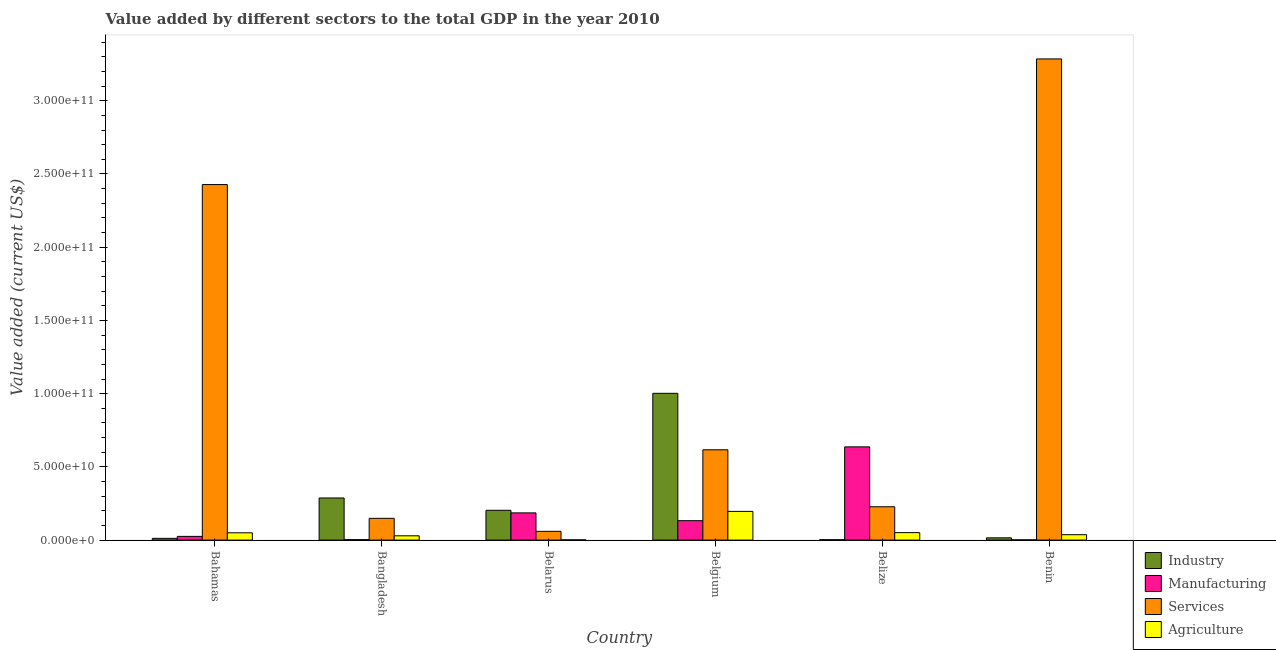Are the number of bars per tick equal to the number of legend labels?
Ensure brevity in your answer.  Yes. Are the number of bars on each tick of the X-axis equal?
Provide a short and direct response. Yes. How many bars are there on the 5th tick from the right?
Give a very brief answer. 4. What is the label of the 4th group of bars from the left?
Keep it short and to the point. Belgium. What is the value added by services sector in Benin?
Ensure brevity in your answer.  3.29e+11. Across all countries, what is the maximum value added by industrial sector?
Provide a short and direct response. 1.00e+11. Across all countries, what is the minimum value added by services sector?
Provide a short and direct response. 5.99e+09. In which country was the value added by agricultural sector maximum?
Keep it short and to the point. Belgium. In which country was the value added by agricultural sector minimum?
Keep it short and to the point. Belarus. What is the total value added by agricultural sector in the graph?
Keep it short and to the point. 3.65e+1. What is the difference between the value added by services sector in Belgium and that in Belize?
Keep it short and to the point. 3.89e+1. What is the difference between the value added by agricultural sector in Benin and the value added by services sector in Belarus?
Offer a very short reply. -2.30e+09. What is the average value added by services sector per country?
Your response must be concise. 1.13e+11. What is the difference between the value added by services sector and value added by agricultural sector in Belize?
Offer a terse response. 1.77e+1. What is the ratio of the value added by industrial sector in Bangladesh to that in Belize?
Ensure brevity in your answer.  109.35. Is the value added by agricultural sector in Bangladesh less than that in Belize?
Your answer should be very brief. Yes. Is the difference between the value added by manufacturing sector in Bangladesh and Belgium greater than the difference between the value added by services sector in Bangladesh and Belgium?
Offer a very short reply. Yes. What is the difference between the highest and the second highest value added by agricultural sector?
Keep it short and to the point. 1.45e+1. What is the difference between the highest and the lowest value added by agricultural sector?
Your answer should be very brief. 1.94e+1. Is the sum of the value added by industrial sector in Belgium and Belize greater than the maximum value added by services sector across all countries?
Ensure brevity in your answer.  No. What does the 4th bar from the left in Belgium represents?
Your response must be concise. Agriculture. What does the 2nd bar from the right in Bahamas represents?
Make the answer very short. Services. Is it the case that in every country, the sum of the value added by industrial sector and value added by manufacturing sector is greater than the value added by services sector?
Keep it short and to the point. No. Are all the bars in the graph horizontal?
Give a very brief answer. No. What is the difference between two consecutive major ticks on the Y-axis?
Make the answer very short. 5.00e+1. Are the values on the major ticks of Y-axis written in scientific E-notation?
Provide a short and direct response. Yes. Does the graph contain any zero values?
Offer a very short reply. No. Does the graph contain grids?
Offer a terse response. No. How many legend labels are there?
Provide a succinct answer. 4. How are the legend labels stacked?
Make the answer very short. Vertical. What is the title of the graph?
Offer a terse response. Value added by different sectors to the total GDP in the year 2010. Does "Taxes on income" appear as one of the legend labels in the graph?
Keep it short and to the point. No. What is the label or title of the Y-axis?
Your response must be concise. Value added (current US$). What is the Value added (current US$) in Industry in Bahamas?
Your response must be concise. 1.20e+09. What is the Value added (current US$) of Manufacturing in Bahamas?
Make the answer very short. 2.54e+09. What is the Value added (current US$) of Services in Bahamas?
Offer a terse response. 2.43e+11. What is the Value added (current US$) of Agriculture in Bahamas?
Offer a very short reply. 4.98e+09. What is the Value added (current US$) of Industry in Bangladesh?
Your answer should be very brief. 2.88e+1. What is the Value added (current US$) in Manufacturing in Bangladesh?
Offer a very short reply. 2.96e+08. What is the Value added (current US$) in Services in Bangladesh?
Your answer should be compact. 1.49e+1. What is the Value added (current US$) of Agriculture in Bangladesh?
Offer a very short reply. 2.93e+09. What is the Value added (current US$) of Industry in Belarus?
Provide a succinct answer. 2.03e+1. What is the Value added (current US$) in Manufacturing in Belarus?
Your response must be concise. 1.86e+1. What is the Value added (current US$) of Services in Belarus?
Your response must be concise. 5.99e+09. What is the Value added (current US$) in Agriculture in Belarus?
Offer a very short reply. 1.70e+08. What is the Value added (current US$) of Industry in Belgium?
Give a very brief answer. 1.00e+11. What is the Value added (current US$) of Manufacturing in Belgium?
Offer a very short reply. 1.33e+1. What is the Value added (current US$) in Services in Belgium?
Offer a terse response. 6.17e+1. What is the Value added (current US$) of Agriculture in Belgium?
Give a very brief answer. 1.96e+1. What is the Value added (current US$) of Industry in Belize?
Offer a very short reply. 2.63e+08. What is the Value added (current US$) of Manufacturing in Belize?
Keep it short and to the point. 6.37e+1. What is the Value added (current US$) of Services in Belize?
Provide a succinct answer. 2.28e+1. What is the Value added (current US$) in Agriculture in Belize?
Ensure brevity in your answer.  5.10e+09. What is the Value added (current US$) in Industry in Benin?
Provide a short and direct response. 1.54e+09. What is the Value added (current US$) in Manufacturing in Benin?
Your response must be concise. 1.71e+08. What is the Value added (current US$) in Services in Benin?
Provide a succinct answer. 3.29e+11. What is the Value added (current US$) in Agriculture in Benin?
Provide a succinct answer. 3.69e+09. Across all countries, what is the maximum Value added (current US$) of Industry?
Ensure brevity in your answer.  1.00e+11. Across all countries, what is the maximum Value added (current US$) in Manufacturing?
Offer a very short reply. 6.37e+1. Across all countries, what is the maximum Value added (current US$) of Services?
Provide a short and direct response. 3.29e+11. Across all countries, what is the maximum Value added (current US$) in Agriculture?
Your answer should be very brief. 1.96e+1. Across all countries, what is the minimum Value added (current US$) of Industry?
Provide a short and direct response. 2.63e+08. Across all countries, what is the minimum Value added (current US$) of Manufacturing?
Your response must be concise. 1.71e+08. Across all countries, what is the minimum Value added (current US$) in Services?
Make the answer very short. 5.99e+09. Across all countries, what is the minimum Value added (current US$) in Agriculture?
Your response must be concise. 1.70e+08. What is the total Value added (current US$) in Industry in the graph?
Offer a very short reply. 1.52e+11. What is the total Value added (current US$) in Manufacturing in the graph?
Provide a short and direct response. 9.85e+1. What is the total Value added (current US$) of Services in the graph?
Your response must be concise. 6.77e+11. What is the total Value added (current US$) of Agriculture in the graph?
Your answer should be very brief. 3.65e+1. What is the difference between the Value added (current US$) of Industry in Bahamas and that in Bangladesh?
Ensure brevity in your answer.  -2.76e+1. What is the difference between the Value added (current US$) in Manufacturing in Bahamas and that in Bangladesh?
Your response must be concise. 2.25e+09. What is the difference between the Value added (current US$) of Services in Bahamas and that in Bangladesh?
Offer a terse response. 2.28e+11. What is the difference between the Value added (current US$) of Agriculture in Bahamas and that in Bangladesh?
Your answer should be very brief. 2.05e+09. What is the difference between the Value added (current US$) of Industry in Bahamas and that in Belarus?
Make the answer very short. -1.92e+1. What is the difference between the Value added (current US$) of Manufacturing in Bahamas and that in Belarus?
Keep it short and to the point. -1.60e+1. What is the difference between the Value added (current US$) in Services in Bahamas and that in Belarus?
Provide a succinct answer. 2.37e+11. What is the difference between the Value added (current US$) of Agriculture in Bahamas and that in Belarus?
Offer a terse response. 4.81e+09. What is the difference between the Value added (current US$) of Industry in Bahamas and that in Belgium?
Make the answer very short. -9.90e+1. What is the difference between the Value added (current US$) of Manufacturing in Bahamas and that in Belgium?
Provide a succinct answer. -1.07e+1. What is the difference between the Value added (current US$) in Services in Bahamas and that in Belgium?
Offer a terse response. 1.81e+11. What is the difference between the Value added (current US$) in Agriculture in Bahamas and that in Belgium?
Make the answer very short. -1.46e+1. What is the difference between the Value added (current US$) of Industry in Bahamas and that in Belize?
Keep it short and to the point. 9.34e+08. What is the difference between the Value added (current US$) in Manufacturing in Bahamas and that in Belize?
Provide a succinct answer. -6.11e+1. What is the difference between the Value added (current US$) of Services in Bahamas and that in Belize?
Offer a very short reply. 2.20e+11. What is the difference between the Value added (current US$) of Agriculture in Bahamas and that in Belize?
Your response must be concise. -1.13e+08. What is the difference between the Value added (current US$) in Industry in Bahamas and that in Benin?
Provide a short and direct response. -3.46e+08. What is the difference between the Value added (current US$) of Manufacturing in Bahamas and that in Benin?
Your answer should be compact. 2.37e+09. What is the difference between the Value added (current US$) of Services in Bahamas and that in Benin?
Ensure brevity in your answer.  -8.58e+1. What is the difference between the Value added (current US$) of Agriculture in Bahamas and that in Benin?
Your answer should be compact. 1.30e+09. What is the difference between the Value added (current US$) of Industry in Bangladesh and that in Belarus?
Your answer should be very brief. 8.42e+09. What is the difference between the Value added (current US$) in Manufacturing in Bangladesh and that in Belarus?
Provide a short and direct response. -1.83e+1. What is the difference between the Value added (current US$) of Services in Bangladesh and that in Belarus?
Your answer should be very brief. 8.88e+09. What is the difference between the Value added (current US$) of Agriculture in Bangladesh and that in Belarus?
Offer a very short reply. 2.76e+09. What is the difference between the Value added (current US$) of Industry in Bangladesh and that in Belgium?
Offer a terse response. -7.15e+1. What is the difference between the Value added (current US$) of Manufacturing in Bangladesh and that in Belgium?
Make the answer very short. -1.30e+1. What is the difference between the Value added (current US$) in Services in Bangladesh and that in Belgium?
Provide a short and direct response. -4.68e+1. What is the difference between the Value added (current US$) in Agriculture in Bangladesh and that in Belgium?
Give a very brief answer. -1.67e+1. What is the difference between the Value added (current US$) in Industry in Bangladesh and that in Belize?
Your answer should be very brief. 2.85e+1. What is the difference between the Value added (current US$) in Manufacturing in Bangladesh and that in Belize?
Make the answer very short. -6.34e+1. What is the difference between the Value added (current US$) in Services in Bangladesh and that in Belize?
Offer a terse response. -7.90e+09. What is the difference between the Value added (current US$) in Agriculture in Bangladesh and that in Belize?
Make the answer very short. -2.16e+09. What is the difference between the Value added (current US$) of Industry in Bangladesh and that in Benin?
Ensure brevity in your answer.  2.72e+1. What is the difference between the Value added (current US$) of Manufacturing in Bangladesh and that in Benin?
Keep it short and to the point. 1.26e+08. What is the difference between the Value added (current US$) of Services in Bangladesh and that in Benin?
Offer a terse response. -3.14e+11. What is the difference between the Value added (current US$) in Agriculture in Bangladesh and that in Benin?
Make the answer very short. -7.54e+08. What is the difference between the Value added (current US$) in Industry in Belarus and that in Belgium?
Give a very brief answer. -7.99e+1. What is the difference between the Value added (current US$) in Manufacturing in Belarus and that in Belgium?
Your answer should be very brief. 5.32e+09. What is the difference between the Value added (current US$) of Services in Belarus and that in Belgium?
Your answer should be compact. -5.57e+1. What is the difference between the Value added (current US$) in Agriculture in Belarus and that in Belgium?
Offer a terse response. -1.94e+1. What is the difference between the Value added (current US$) of Industry in Belarus and that in Belize?
Your response must be concise. 2.01e+1. What is the difference between the Value added (current US$) of Manufacturing in Belarus and that in Belize?
Offer a very short reply. -4.51e+1. What is the difference between the Value added (current US$) of Services in Belarus and that in Belize?
Keep it short and to the point. -1.68e+1. What is the difference between the Value added (current US$) of Agriculture in Belarus and that in Belize?
Provide a succinct answer. -4.93e+09. What is the difference between the Value added (current US$) of Industry in Belarus and that in Benin?
Provide a succinct answer. 1.88e+1. What is the difference between the Value added (current US$) in Manufacturing in Belarus and that in Benin?
Give a very brief answer. 1.84e+1. What is the difference between the Value added (current US$) in Services in Belarus and that in Benin?
Your response must be concise. -3.23e+11. What is the difference between the Value added (current US$) in Agriculture in Belarus and that in Benin?
Your answer should be very brief. -3.52e+09. What is the difference between the Value added (current US$) in Industry in Belgium and that in Belize?
Provide a succinct answer. 1.00e+11. What is the difference between the Value added (current US$) of Manufacturing in Belgium and that in Belize?
Your response must be concise. -5.04e+1. What is the difference between the Value added (current US$) of Services in Belgium and that in Belize?
Your response must be concise. 3.89e+1. What is the difference between the Value added (current US$) in Agriculture in Belgium and that in Belize?
Your response must be concise. 1.45e+1. What is the difference between the Value added (current US$) in Industry in Belgium and that in Benin?
Your answer should be compact. 9.87e+1. What is the difference between the Value added (current US$) of Manufacturing in Belgium and that in Benin?
Give a very brief answer. 1.31e+1. What is the difference between the Value added (current US$) in Services in Belgium and that in Benin?
Offer a very short reply. -2.67e+11. What is the difference between the Value added (current US$) in Agriculture in Belgium and that in Benin?
Offer a very short reply. 1.59e+1. What is the difference between the Value added (current US$) in Industry in Belize and that in Benin?
Provide a succinct answer. -1.28e+09. What is the difference between the Value added (current US$) in Manufacturing in Belize and that in Benin?
Ensure brevity in your answer.  6.35e+1. What is the difference between the Value added (current US$) in Services in Belize and that in Benin?
Provide a succinct answer. -3.06e+11. What is the difference between the Value added (current US$) of Agriculture in Belize and that in Benin?
Your answer should be very brief. 1.41e+09. What is the difference between the Value added (current US$) of Industry in Bahamas and the Value added (current US$) of Manufacturing in Bangladesh?
Keep it short and to the point. 9.01e+08. What is the difference between the Value added (current US$) in Industry in Bahamas and the Value added (current US$) in Services in Bangladesh?
Give a very brief answer. -1.37e+1. What is the difference between the Value added (current US$) in Industry in Bahamas and the Value added (current US$) in Agriculture in Bangladesh?
Your answer should be very brief. -1.74e+09. What is the difference between the Value added (current US$) of Manufacturing in Bahamas and the Value added (current US$) of Services in Bangladesh?
Provide a short and direct response. -1.23e+1. What is the difference between the Value added (current US$) in Manufacturing in Bahamas and the Value added (current US$) in Agriculture in Bangladesh?
Your response must be concise. -3.90e+08. What is the difference between the Value added (current US$) in Services in Bahamas and the Value added (current US$) in Agriculture in Bangladesh?
Keep it short and to the point. 2.40e+11. What is the difference between the Value added (current US$) of Industry in Bahamas and the Value added (current US$) of Manufacturing in Belarus?
Make the answer very short. -1.74e+1. What is the difference between the Value added (current US$) of Industry in Bahamas and the Value added (current US$) of Services in Belarus?
Offer a terse response. -4.79e+09. What is the difference between the Value added (current US$) in Industry in Bahamas and the Value added (current US$) in Agriculture in Belarus?
Offer a very short reply. 1.03e+09. What is the difference between the Value added (current US$) of Manufacturing in Bahamas and the Value added (current US$) of Services in Belarus?
Provide a short and direct response. -3.44e+09. What is the difference between the Value added (current US$) of Manufacturing in Bahamas and the Value added (current US$) of Agriculture in Belarus?
Your response must be concise. 2.37e+09. What is the difference between the Value added (current US$) in Services in Bahamas and the Value added (current US$) in Agriculture in Belarus?
Give a very brief answer. 2.43e+11. What is the difference between the Value added (current US$) of Industry in Bahamas and the Value added (current US$) of Manufacturing in Belgium?
Offer a very short reply. -1.21e+1. What is the difference between the Value added (current US$) of Industry in Bahamas and the Value added (current US$) of Services in Belgium?
Make the answer very short. -6.05e+1. What is the difference between the Value added (current US$) in Industry in Bahamas and the Value added (current US$) in Agriculture in Belgium?
Keep it short and to the point. -1.84e+1. What is the difference between the Value added (current US$) of Manufacturing in Bahamas and the Value added (current US$) of Services in Belgium?
Keep it short and to the point. -5.91e+1. What is the difference between the Value added (current US$) of Manufacturing in Bahamas and the Value added (current US$) of Agriculture in Belgium?
Give a very brief answer. -1.71e+1. What is the difference between the Value added (current US$) of Services in Bahamas and the Value added (current US$) of Agriculture in Belgium?
Provide a short and direct response. 2.23e+11. What is the difference between the Value added (current US$) in Industry in Bahamas and the Value added (current US$) in Manufacturing in Belize?
Provide a succinct answer. -6.25e+1. What is the difference between the Value added (current US$) in Industry in Bahamas and the Value added (current US$) in Services in Belize?
Offer a very short reply. -2.16e+1. What is the difference between the Value added (current US$) of Industry in Bahamas and the Value added (current US$) of Agriculture in Belize?
Give a very brief answer. -3.90e+09. What is the difference between the Value added (current US$) of Manufacturing in Bahamas and the Value added (current US$) of Services in Belize?
Keep it short and to the point. -2.02e+1. What is the difference between the Value added (current US$) of Manufacturing in Bahamas and the Value added (current US$) of Agriculture in Belize?
Offer a very short reply. -2.55e+09. What is the difference between the Value added (current US$) in Services in Bahamas and the Value added (current US$) in Agriculture in Belize?
Offer a very short reply. 2.38e+11. What is the difference between the Value added (current US$) in Industry in Bahamas and the Value added (current US$) in Manufacturing in Benin?
Your answer should be compact. 1.03e+09. What is the difference between the Value added (current US$) in Industry in Bahamas and the Value added (current US$) in Services in Benin?
Provide a short and direct response. -3.27e+11. What is the difference between the Value added (current US$) of Industry in Bahamas and the Value added (current US$) of Agriculture in Benin?
Ensure brevity in your answer.  -2.49e+09. What is the difference between the Value added (current US$) in Manufacturing in Bahamas and the Value added (current US$) in Services in Benin?
Provide a short and direct response. -3.26e+11. What is the difference between the Value added (current US$) in Manufacturing in Bahamas and the Value added (current US$) in Agriculture in Benin?
Provide a short and direct response. -1.14e+09. What is the difference between the Value added (current US$) in Services in Bahamas and the Value added (current US$) in Agriculture in Benin?
Give a very brief answer. 2.39e+11. What is the difference between the Value added (current US$) in Industry in Bangladesh and the Value added (current US$) in Manufacturing in Belarus?
Your answer should be compact. 1.02e+1. What is the difference between the Value added (current US$) in Industry in Bangladesh and the Value added (current US$) in Services in Belarus?
Provide a succinct answer. 2.28e+1. What is the difference between the Value added (current US$) of Industry in Bangladesh and the Value added (current US$) of Agriculture in Belarus?
Your answer should be compact. 2.86e+1. What is the difference between the Value added (current US$) of Manufacturing in Bangladesh and the Value added (current US$) of Services in Belarus?
Provide a short and direct response. -5.69e+09. What is the difference between the Value added (current US$) of Manufacturing in Bangladesh and the Value added (current US$) of Agriculture in Belarus?
Your answer should be very brief. 1.26e+08. What is the difference between the Value added (current US$) of Services in Bangladesh and the Value added (current US$) of Agriculture in Belarus?
Your answer should be compact. 1.47e+1. What is the difference between the Value added (current US$) in Industry in Bangladesh and the Value added (current US$) in Manufacturing in Belgium?
Your answer should be very brief. 1.55e+1. What is the difference between the Value added (current US$) in Industry in Bangladesh and the Value added (current US$) in Services in Belgium?
Give a very brief answer. -3.29e+1. What is the difference between the Value added (current US$) in Industry in Bangladesh and the Value added (current US$) in Agriculture in Belgium?
Offer a terse response. 9.17e+09. What is the difference between the Value added (current US$) in Manufacturing in Bangladesh and the Value added (current US$) in Services in Belgium?
Give a very brief answer. -6.14e+1. What is the difference between the Value added (current US$) in Manufacturing in Bangladesh and the Value added (current US$) in Agriculture in Belgium?
Your answer should be compact. -1.93e+1. What is the difference between the Value added (current US$) of Services in Bangladesh and the Value added (current US$) of Agriculture in Belgium?
Make the answer very short. -4.73e+09. What is the difference between the Value added (current US$) of Industry in Bangladesh and the Value added (current US$) of Manufacturing in Belize?
Ensure brevity in your answer.  -3.49e+1. What is the difference between the Value added (current US$) in Industry in Bangladesh and the Value added (current US$) in Services in Belize?
Offer a very short reply. 6.00e+09. What is the difference between the Value added (current US$) in Industry in Bangladesh and the Value added (current US$) in Agriculture in Belize?
Give a very brief answer. 2.37e+1. What is the difference between the Value added (current US$) in Manufacturing in Bangladesh and the Value added (current US$) in Services in Belize?
Make the answer very short. -2.25e+1. What is the difference between the Value added (current US$) of Manufacturing in Bangladesh and the Value added (current US$) of Agriculture in Belize?
Make the answer very short. -4.80e+09. What is the difference between the Value added (current US$) in Services in Bangladesh and the Value added (current US$) in Agriculture in Belize?
Keep it short and to the point. 9.77e+09. What is the difference between the Value added (current US$) in Industry in Bangladesh and the Value added (current US$) in Manufacturing in Benin?
Your answer should be very brief. 2.86e+1. What is the difference between the Value added (current US$) of Industry in Bangladesh and the Value added (current US$) of Services in Benin?
Ensure brevity in your answer.  -3.00e+11. What is the difference between the Value added (current US$) in Industry in Bangladesh and the Value added (current US$) in Agriculture in Benin?
Ensure brevity in your answer.  2.51e+1. What is the difference between the Value added (current US$) in Manufacturing in Bangladesh and the Value added (current US$) in Services in Benin?
Your answer should be compact. -3.28e+11. What is the difference between the Value added (current US$) in Manufacturing in Bangladesh and the Value added (current US$) in Agriculture in Benin?
Your response must be concise. -3.39e+09. What is the difference between the Value added (current US$) in Services in Bangladesh and the Value added (current US$) in Agriculture in Benin?
Your answer should be compact. 1.12e+1. What is the difference between the Value added (current US$) of Industry in Belarus and the Value added (current US$) of Manufacturing in Belgium?
Your answer should be very brief. 7.08e+09. What is the difference between the Value added (current US$) in Industry in Belarus and the Value added (current US$) in Services in Belgium?
Keep it short and to the point. -4.13e+1. What is the difference between the Value added (current US$) in Industry in Belarus and the Value added (current US$) in Agriculture in Belgium?
Your response must be concise. 7.50e+08. What is the difference between the Value added (current US$) in Manufacturing in Belarus and the Value added (current US$) in Services in Belgium?
Ensure brevity in your answer.  -4.31e+1. What is the difference between the Value added (current US$) of Manufacturing in Belarus and the Value added (current US$) of Agriculture in Belgium?
Your answer should be compact. -1.01e+09. What is the difference between the Value added (current US$) of Services in Belarus and the Value added (current US$) of Agriculture in Belgium?
Provide a succinct answer. -1.36e+1. What is the difference between the Value added (current US$) in Industry in Belarus and the Value added (current US$) in Manufacturing in Belize?
Offer a terse response. -4.33e+1. What is the difference between the Value added (current US$) in Industry in Belarus and the Value added (current US$) in Services in Belize?
Ensure brevity in your answer.  -2.42e+09. What is the difference between the Value added (current US$) of Industry in Belarus and the Value added (current US$) of Agriculture in Belize?
Your answer should be very brief. 1.53e+1. What is the difference between the Value added (current US$) of Manufacturing in Belarus and the Value added (current US$) of Services in Belize?
Give a very brief answer. -4.19e+09. What is the difference between the Value added (current US$) in Manufacturing in Belarus and the Value added (current US$) in Agriculture in Belize?
Your response must be concise. 1.35e+1. What is the difference between the Value added (current US$) of Services in Belarus and the Value added (current US$) of Agriculture in Belize?
Keep it short and to the point. 8.90e+08. What is the difference between the Value added (current US$) of Industry in Belarus and the Value added (current US$) of Manufacturing in Benin?
Your answer should be very brief. 2.02e+1. What is the difference between the Value added (current US$) of Industry in Belarus and the Value added (current US$) of Services in Benin?
Make the answer very short. -3.08e+11. What is the difference between the Value added (current US$) in Industry in Belarus and the Value added (current US$) in Agriculture in Benin?
Your response must be concise. 1.67e+1. What is the difference between the Value added (current US$) of Manufacturing in Belarus and the Value added (current US$) of Services in Benin?
Your answer should be compact. -3.10e+11. What is the difference between the Value added (current US$) in Manufacturing in Belarus and the Value added (current US$) in Agriculture in Benin?
Provide a short and direct response. 1.49e+1. What is the difference between the Value added (current US$) in Services in Belarus and the Value added (current US$) in Agriculture in Benin?
Give a very brief answer. 2.30e+09. What is the difference between the Value added (current US$) of Industry in Belgium and the Value added (current US$) of Manufacturing in Belize?
Provide a succinct answer. 3.66e+1. What is the difference between the Value added (current US$) in Industry in Belgium and the Value added (current US$) in Services in Belize?
Ensure brevity in your answer.  7.75e+1. What is the difference between the Value added (current US$) in Industry in Belgium and the Value added (current US$) in Agriculture in Belize?
Offer a terse response. 9.51e+1. What is the difference between the Value added (current US$) of Manufacturing in Belgium and the Value added (current US$) of Services in Belize?
Offer a terse response. -9.50e+09. What is the difference between the Value added (current US$) in Manufacturing in Belgium and the Value added (current US$) in Agriculture in Belize?
Provide a short and direct response. 8.17e+09. What is the difference between the Value added (current US$) in Services in Belgium and the Value added (current US$) in Agriculture in Belize?
Your answer should be very brief. 5.66e+1. What is the difference between the Value added (current US$) of Industry in Belgium and the Value added (current US$) of Manufacturing in Benin?
Offer a terse response. 1.00e+11. What is the difference between the Value added (current US$) in Industry in Belgium and the Value added (current US$) in Services in Benin?
Provide a short and direct response. -2.28e+11. What is the difference between the Value added (current US$) in Industry in Belgium and the Value added (current US$) in Agriculture in Benin?
Offer a terse response. 9.65e+1. What is the difference between the Value added (current US$) in Manufacturing in Belgium and the Value added (current US$) in Services in Benin?
Your response must be concise. -3.15e+11. What is the difference between the Value added (current US$) in Manufacturing in Belgium and the Value added (current US$) in Agriculture in Benin?
Keep it short and to the point. 9.58e+09. What is the difference between the Value added (current US$) in Services in Belgium and the Value added (current US$) in Agriculture in Benin?
Offer a terse response. 5.80e+1. What is the difference between the Value added (current US$) of Industry in Belize and the Value added (current US$) of Manufacturing in Benin?
Your response must be concise. 9.25e+07. What is the difference between the Value added (current US$) of Industry in Belize and the Value added (current US$) of Services in Benin?
Offer a very short reply. -3.28e+11. What is the difference between the Value added (current US$) of Industry in Belize and the Value added (current US$) of Agriculture in Benin?
Make the answer very short. -3.42e+09. What is the difference between the Value added (current US$) in Manufacturing in Belize and the Value added (current US$) in Services in Benin?
Give a very brief answer. -2.65e+11. What is the difference between the Value added (current US$) in Manufacturing in Belize and the Value added (current US$) in Agriculture in Benin?
Offer a very short reply. 6.00e+1. What is the difference between the Value added (current US$) of Services in Belize and the Value added (current US$) of Agriculture in Benin?
Provide a short and direct response. 1.91e+1. What is the average Value added (current US$) in Industry per country?
Offer a terse response. 2.54e+1. What is the average Value added (current US$) in Manufacturing per country?
Keep it short and to the point. 1.64e+1. What is the average Value added (current US$) of Services per country?
Your response must be concise. 1.13e+11. What is the average Value added (current US$) in Agriculture per country?
Offer a terse response. 6.08e+09. What is the difference between the Value added (current US$) of Industry and Value added (current US$) of Manufacturing in Bahamas?
Your answer should be compact. -1.35e+09. What is the difference between the Value added (current US$) of Industry and Value added (current US$) of Services in Bahamas?
Your answer should be very brief. -2.42e+11. What is the difference between the Value added (current US$) in Industry and Value added (current US$) in Agriculture in Bahamas?
Provide a succinct answer. -3.79e+09. What is the difference between the Value added (current US$) in Manufacturing and Value added (current US$) in Services in Bahamas?
Your answer should be very brief. -2.40e+11. What is the difference between the Value added (current US$) of Manufacturing and Value added (current US$) of Agriculture in Bahamas?
Offer a very short reply. -2.44e+09. What is the difference between the Value added (current US$) of Services and Value added (current US$) of Agriculture in Bahamas?
Ensure brevity in your answer.  2.38e+11. What is the difference between the Value added (current US$) in Industry and Value added (current US$) in Manufacturing in Bangladesh?
Make the answer very short. 2.85e+1. What is the difference between the Value added (current US$) in Industry and Value added (current US$) in Services in Bangladesh?
Offer a very short reply. 1.39e+1. What is the difference between the Value added (current US$) of Industry and Value added (current US$) of Agriculture in Bangladesh?
Keep it short and to the point. 2.58e+1. What is the difference between the Value added (current US$) in Manufacturing and Value added (current US$) in Services in Bangladesh?
Keep it short and to the point. -1.46e+1. What is the difference between the Value added (current US$) of Manufacturing and Value added (current US$) of Agriculture in Bangladesh?
Your answer should be very brief. -2.64e+09. What is the difference between the Value added (current US$) in Services and Value added (current US$) in Agriculture in Bangladesh?
Offer a terse response. 1.19e+1. What is the difference between the Value added (current US$) in Industry and Value added (current US$) in Manufacturing in Belarus?
Give a very brief answer. 1.76e+09. What is the difference between the Value added (current US$) of Industry and Value added (current US$) of Services in Belarus?
Provide a short and direct response. 1.44e+1. What is the difference between the Value added (current US$) in Industry and Value added (current US$) in Agriculture in Belarus?
Keep it short and to the point. 2.02e+1. What is the difference between the Value added (current US$) in Manufacturing and Value added (current US$) in Services in Belarus?
Offer a terse response. 1.26e+1. What is the difference between the Value added (current US$) in Manufacturing and Value added (current US$) in Agriculture in Belarus?
Offer a very short reply. 1.84e+1. What is the difference between the Value added (current US$) in Services and Value added (current US$) in Agriculture in Belarus?
Give a very brief answer. 5.82e+09. What is the difference between the Value added (current US$) in Industry and Value added (current US$) in Manufacturing in Belgium?
Offer a very short reply. 8.70e+1. What is the difference between the Value added (current US$) of Industry and Value added (current US$) of Services in Belgium?
Offer a terse response. 3.86e+1. What is the difference between the Value added (current US$) in Industry and Value added (current US$) in Agriculture in Belgium?
Make the answer very short. 8.06e+1. What is the difference between the Value added (current US$) in Manufacturing and Value added (current US$) in Services in Belgium?
Keep it short and to the point. -4.84e+1. What is the difference between the Value added (current US$) in Manufacturing and Value added (current US$) in Agriculture in Belgium?
Ensure brevity in your answer.  -6.33e+09. What is the difference between the Value added (current US$) in Services and Value added (current US$) in Agriculture in Belgium?
Give a very brief answer. 4.21e+1. What is the difference between the Value added (current US$) in Industry and Value added (current US$) in Manufacturing in Belize?
Your response must be concise. -6.34e+1. What is the difference between the Value added (current US$) in Industry and Value added (current US$) in Services in Belize?
Offer a terse response. -2.25e+1. What is the difference between the Value added (current US$) in Industry and Value added (current US$) in Agriculture in Belize?
Provide a short and direct response. -4.83e+09. What is the difference between the Value added (current US$) of Manufacturing and Value added (current US$) of Services in Belize?
Offer a very short reply. 4.09e+1. What is the difference between the Value added (current US$) in Manufacturing and Value added (current US$) in Agriculture in Belize?
Provide a short and direct response. 5.86e+1. What is the difference between the Value added (current US$) of Services and Value added (current US$) of Agriculture in Belize?
Provide a succinct answer. 1.77e+1. What is the difference between the Value added (current US$) of Industry and Value added (current US$) of Manufacturing in Benin?
Your answer should be compact. 1.37e+09. What is the difference between the Value added (current US$) of Industry and Value added (current US$) of Services in Benin?
Your response must be concise. -3.27e+11. What is the difference between the Value added (current US$) in Industry and Value added (current US$) in Agriculture in Benin?
Provide a succinct answer. -2.14e+09. What is the difference between the Value added (current US$) in Manufacturing and Value added (current US$) in Services in Benin?
Ensure brevity in your answer.  -3.28e+11. What is the difference between the Value added (current US$) of Manufacturing and Value added (current US$) of Agriculture in Benin?
Offer a very short reply. -3.52e+09. What is the difference between the Value added (current US$) of Services and Value added (current US$) of Agriculture in Benin?
Your response must be concise. 3.25e+11. What is the ratio of the Value added (current US$) of Industry in Bahamas to that in Bangladesh?
Provide a succinct answer. 0.04. What is the ratio of the Value added (current US$) in Manufacturing in Bahamas to that in Bangladesh?
Your answer should be compact. 8.58. What is the ratio of the Value added (current US$) of Services in Bahamas to that in Bangladesh?
Give a very brief answer. 16.33. What is the ratio of the Value added (current US$) in Agriculture in Bahamas to that in Bangladesh?
Make the answer very short. 1.7. What is the ratio of the Value added (current US$) of Industry in Bahamas to that in Belarus?
Keep it short and to the point. 0.06. What is the ratio of the Value added (current US$) in Manufacturing in Bahamas to that in Belarus?
Offer a terse response. 0.14. What is the ratio of the Value added (current US$) in Services in Bahamas to that in Belarus?
Make the answer very short. 40.56. What is the ratio of the Value added (current US$) in Agriculture in Bahamas to that in Belarus?
Provide a succinct answer. 29.31. What is the ratio of the Value added (current US$) in Industry in Bahamas to that in Belgium?
Provide a short and direct response. 0.01. What is the ratio of the Value added (current US$) of Manufacturing in Bahamas to that in Belgium?
Make the answer very short. 0.19. What is the ratio of the Value added (current US$) in Services in Bahamas to that in Belgium?
Provide a short and direct response. 3.94. What is the ratio of the Value added (current US$) of Agriculture in Bahamas to that in Belgium?
Your answer should be compact. 0.25. What is the ratio of the Value added (current US$) of Industry in Bahamas to that in Belize?
Keep it short and to the point. 4.55. What is the ratio of the Value added (current US$) in Manufacturing in Bahamas to that in Belize?
Offer a terse response. 0.04. What is the ratio of the Value added (current US$) in Services in Bahamas to that in Belize?
Offer a terse response. 10.66. What is the ratio of the Value added (current US$) of Agriculture in Bahamas to that in Belize?
Ensure brevity in your answer.  0.98. What is the ratio of the Value added (current US$) in Industry in Bahamas to that in Benin?
Provide a short and direct response. 0.78. What is the ratio of the Value added (current US$) in Manufacturing in Bahamas to that in Benin?
Provide a succinct answer. 14.91. What is the ratio of the Value added (current US$) in Services in Bahamas to that in Benin?
Offer a very short reply. 0.74. What is the ratio of the Value added (current US$) in Agriculture in Bahamas to that in Benin?
Offer a very short reply. 1.35. What is the ratio of the Value added (current US$) of Industry in Bangladesh to that in Belarus?
Offer a terse response. 1.41. What is the ratio of the Value added (current US$) of Manufacturing in Bangladesh to that in Belarus?
Your answer should be compact. 0.02. What is the ratio of the Value added (current US$) of Services in Bangladesh to that in Belarus?
Provide a short and direct response. 2.48. What is the ratio of the Value added (current US$) of Agriculture in Bangladesh to that in Belarus?
Make the answer very short. 17.25. What is the ratio of the Value added (current US$) of Industry in Bangladesh to that in Belgium?
Provide a succinct answer. 0.29. What is the ratio of the Value added (current US$) in Manufacturing in Bangladesh to that in Belgium?
Your response must be concise. 0.02. What is the ratio of the Value added (current US$) of Services in Bangladesh to that in Belgium?
Your answer should be compact. 0.24. What is the ratio of the Value added (current US$) in Agriculture in Bangladesh to that in Belgium?
Keep it short and to the point. 0.15. What is the ratio of the Value added (current US$) of Industry in Bangladesh to that in Belize?
Your answer should be very brief. 109.35. What is the ratio of the Value added (current US$) of Manufacturing in Bangladesh to that in Belize?
Keep it short and to the point. 0. What is the ratio of the Value added (current US$) of Services in Bangladesh to that in Belize?
Provide a short and direct response. 0.65. What is the ratio of the Value added (current US$) in Agriculture in Bangladesh to that in Belize?
Your answer should be compact. 0.58. What is the ratio of the Value added (current US$) in Industry in Bangladesh to that in Benin?
Make the answer very short. 18.65. What is the ratio of the Value added (current US$) in Manufacturing in Bangladesh to that in Benin?
Your answer should be very brief. 1.74. What is the ratio of the Value added (current US$) of Services in Bangladesh to that in Benin?
Offer a terse response. 0.05. What is the ratio of the Value added (current US$) in Agriculture in Bangladesh to that in Benin?
Offer a very short reply. 0.8. What is the ratio of the Value added (current US$) of Industry in Belarus to that in Belgium?
Offer a very short reply. 0.2. What is the ratio of the Value added (current US$) in Manufacturing in Belarus to that in Belgium?
Make the answer very short. 1.4. What is the ratio of the Value added (current US$) of Services in Belarus to that in Belgium?
Your answer should be very brief. 0.1. What is the ratio of the Value added (current US$) in Agriculture in Belarus to that in Belgium?
Provide a short and direct response. 0.01. What is the ratio of the Value added (current US$) of Industry in Belarus to that in Belize?
Ensure brevity in your answer.  77.34. What is the ratio of the Value added (current US$) in Manufacturing in Belarus to that in Belize?
Offer a very short reply. 0.29. What is the ratio of the Value added (current US$) in Services in Belarus to that in Belize?
Keep it short and to the point. 0.26. What is the ratio of the Value added (current US$) of Agriculture in Belarus to that in Belize?
Give a very brief answer. 0.03. What is the ratio of the Value added (current US$) in Industry in Belarus to that in Benin?
Your answer should be compact. 13.19. What is the ratio of the Value added (current US$) in Manufacturing in Belarus to that in Benin?
Your answer should be very brief. 108.94. What is the ratio of the Value added (current US$) in Services in Belarus to that in Benin?
Make the answer very short. 0.02. What is the ratio of the Value added (current US$) in Agriculture in Belarus to that in Benin?
Make the answer very short. 0.05. What is the ratio of the Value added (current US$) of Industry in Belgium to that in Belize?
Provide a short and direct response. 380.99. What is the ratio of the Value added (current US$) of Manufacturing in Belgium to that in Belize?
Offer a very short reply. 0.21. What is the ratio of the Value added (current US$) in Services in Belgium to that in Belize?
Offer a terse response. 2.71. What is the ratio of the Value added (current US$) in Agriculture in Belgium to that in Belize?
Keep it short and to the point. 3.85. What is the ratio of the Value added (current US$) of Industry in Belgium to that in Benin?
Keep it short and to the point. 64.96. What is the ratio of the Value added (current US$) of Manufacturing in Belgium to that in Benin?
Provide a short and direct response. 77.76. What is the ratio of the Value added (current US$) of Services in Belgium to that in Benin?
Offer a very short reply. 0.19. What is the ratio of the Value added (current US$) of Agriculture in Belgium to that in Benin?
Your answer should be compact. 5.32. What is the ratio of the Value added (current US$) in Industry in Belize to that in Benin?
Provide a short and direct response. 0.17. What is the ratio of the Value added (current US$) in Manufacturing in Belize to that in Benin?
Provide a succinct answer. 373.21. What is the ratio of the Value added (current US$) of Services in Belize to that in Benin?
Provide a short and direct response. 0.07. What is the ratio of the Value added (current US$) of Agriculture in Belize to that in Benin?
Your response must be concise. 1.38. What is the difference between the highest and the second highest Value added (current US$) of Industry?
Offer a very short reply. 7.15e+1. What is the difference between the highest and the second highest Value added (current US$) in Manufacturing?
Offer a very short reply. 4.51e+1. What is the difference between the highest and the second highest Value added (current US$) of Services?
Make the answer very short. 8.58e+1. What is the difference between the highest and the second highest Value added (current US$) of Agriculture?
Make the answer very short. 1.45e+1. What is the difference between the highest and the lowest Value added (current US$) of Industry?
Your answer should be compact. 1.00e+11. What is the difference between the highest and the lowest Value added (current US$) in Manufacturing?
Provide a succinct answer. 6.35e+1. What is the difference between the highest and the lowest Value added (current US$) in Services?
Ensure brevity in your answer.  3.23e+11. What is the difference between the highest and the lowest Value added (current US$) of Agriculture?
Provide a short and direct response. 1.94e+1. 